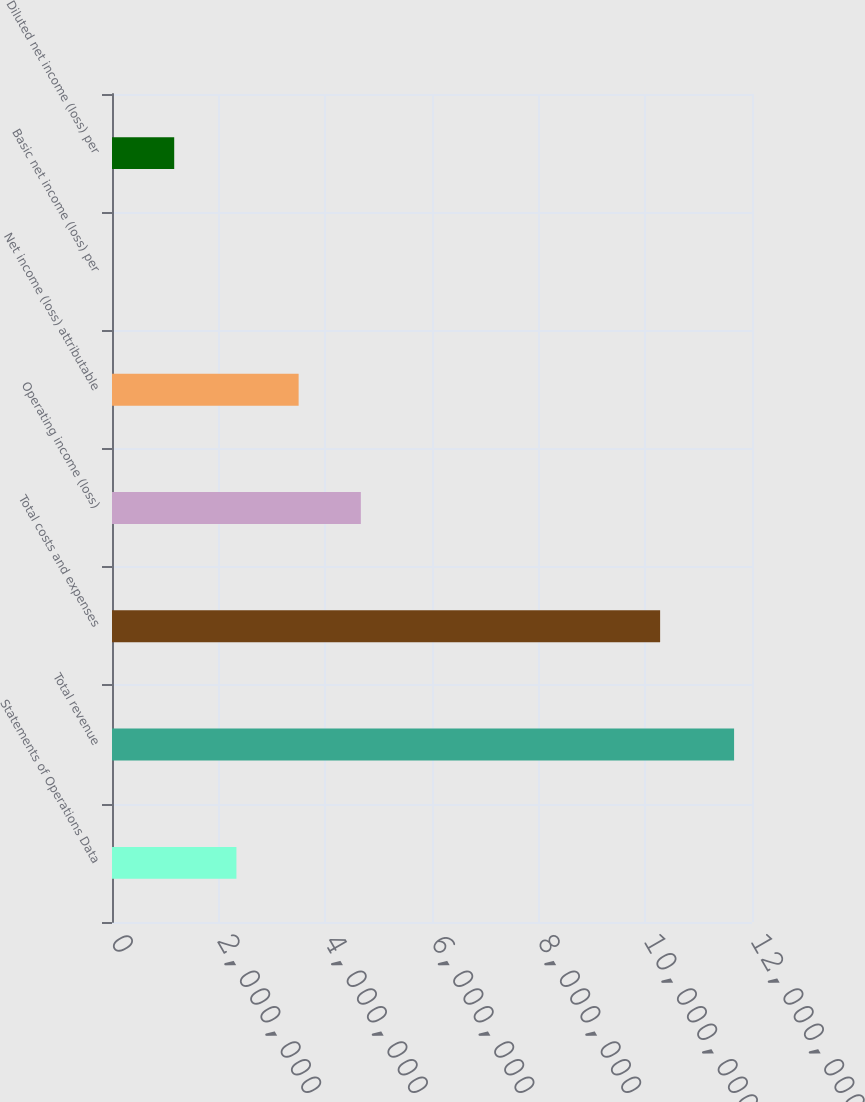Convert chart to OTSL. <chart><loc_0><loc_0><loc_500><loc_500><bar_chart><fcel>Statements of Operations Data<fcel>Total revenue<fcel>Total costs and expenses<fcel>Operating income (loss)<fcel>Net income (loss) attributable<fcel>Basic net income (loss) per<fcel>Diluted net income (loss) per<nl><fcel>2.33283e+06<fcel>1.16642e+07<fcel>1.02772e+07<fcel>4.66566e+06<fcel>3.49925e+06<fcel>1.42<fcel>1.16642e+06<nl></chart> 